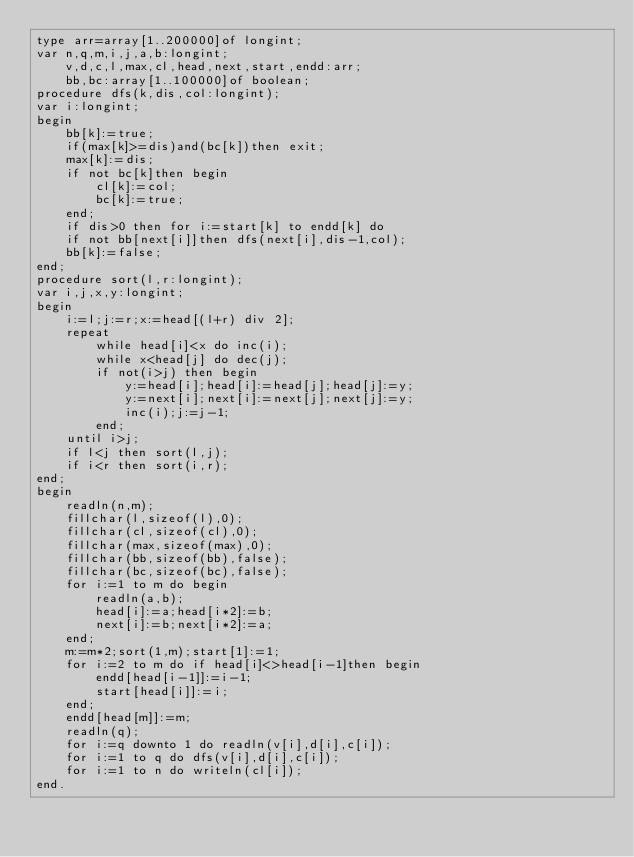<code> <loc_0><loc_0><loc_500><loc_500><_Pascal_>type arr=array[1..200000]of longint;
var n,q,m,i,j,a,b:longint;
    v,d,c,l,max,cl,head,next,start,endd:arr;
    bb,bc:array[1..100000]of boolean;
procedure dfs(k,dis,col:longint);
var i:longint;
begin
    bb[k]:=true;
    if(max[k]>=dis)and(bc[k])then exit;
    max[k]:=dis;
    if not bc[k]then begin
        cl[k]:=col;
        bc[k]:=true;
    end;
    if dis>0 then for i:=start[k] to endd[k] do
    if not bb[next[i]]then dfs(next[i],dis-1,col);
    bb[k]:=false;
end;
procedure sort(l,r:longint);
var i,j,x,y:longint;
begin
    i:=l;j:=r;x:=head[(l+r) div 2];
    repeat
        while head[i]<x do inc(i);
        while x<head[j] do dec(j);
        if not(i>j) then begin
            y:=head[i];head[i]:=head[j];head[j]:=y;
            y:=next[i];next[i]:=next[j];next[j]:=y;
            inc(i);j:=j-1;
        end;
    until i>j;
    if l<j then sort(l,j);
    if i<r then sort(i,r);
end;
begin
    readln(n,m);
    fillchar(l,sizeof(l),0);
    fillchar(cl,sizeof(cl),0);
    fillchar(max,sizeof(max),0);
    fillchar(bb,sizeof(bb),false);
    fillchar(bc,sizeof(bc),false);
    for i:=1 to m do begin
        readln(a,b);
        head[i]:=a;head[i*2]:=b;
        next[i]:=b;next[i*2]:=a;
    end;
    m:=m*2;sort(1,m);start[1]:=1;
    for i:=2 to m do if head[i]<>head[i-1]then begin
        endd[head[i-1]]:=i-1;
        start[head[i]]:=i;
    end;
    endd[head[m]]:=m;
    readln(q);
    for i:=q downto 1 do readln(v[i],d[i],c[i]);
    for i:=1 to q do dfs(v[i],d[i],c[i]);
    for i:=1 to n do writeln(cl[i]);
end.</code> 